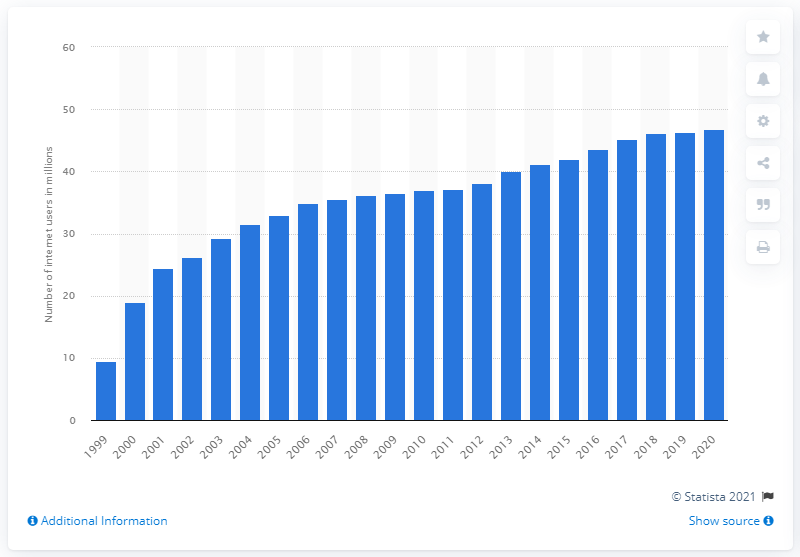Highlight a few significant elements in this photo. During the period of 1999 to 2020, there were approximately 46.82 internet users in South Korea. 